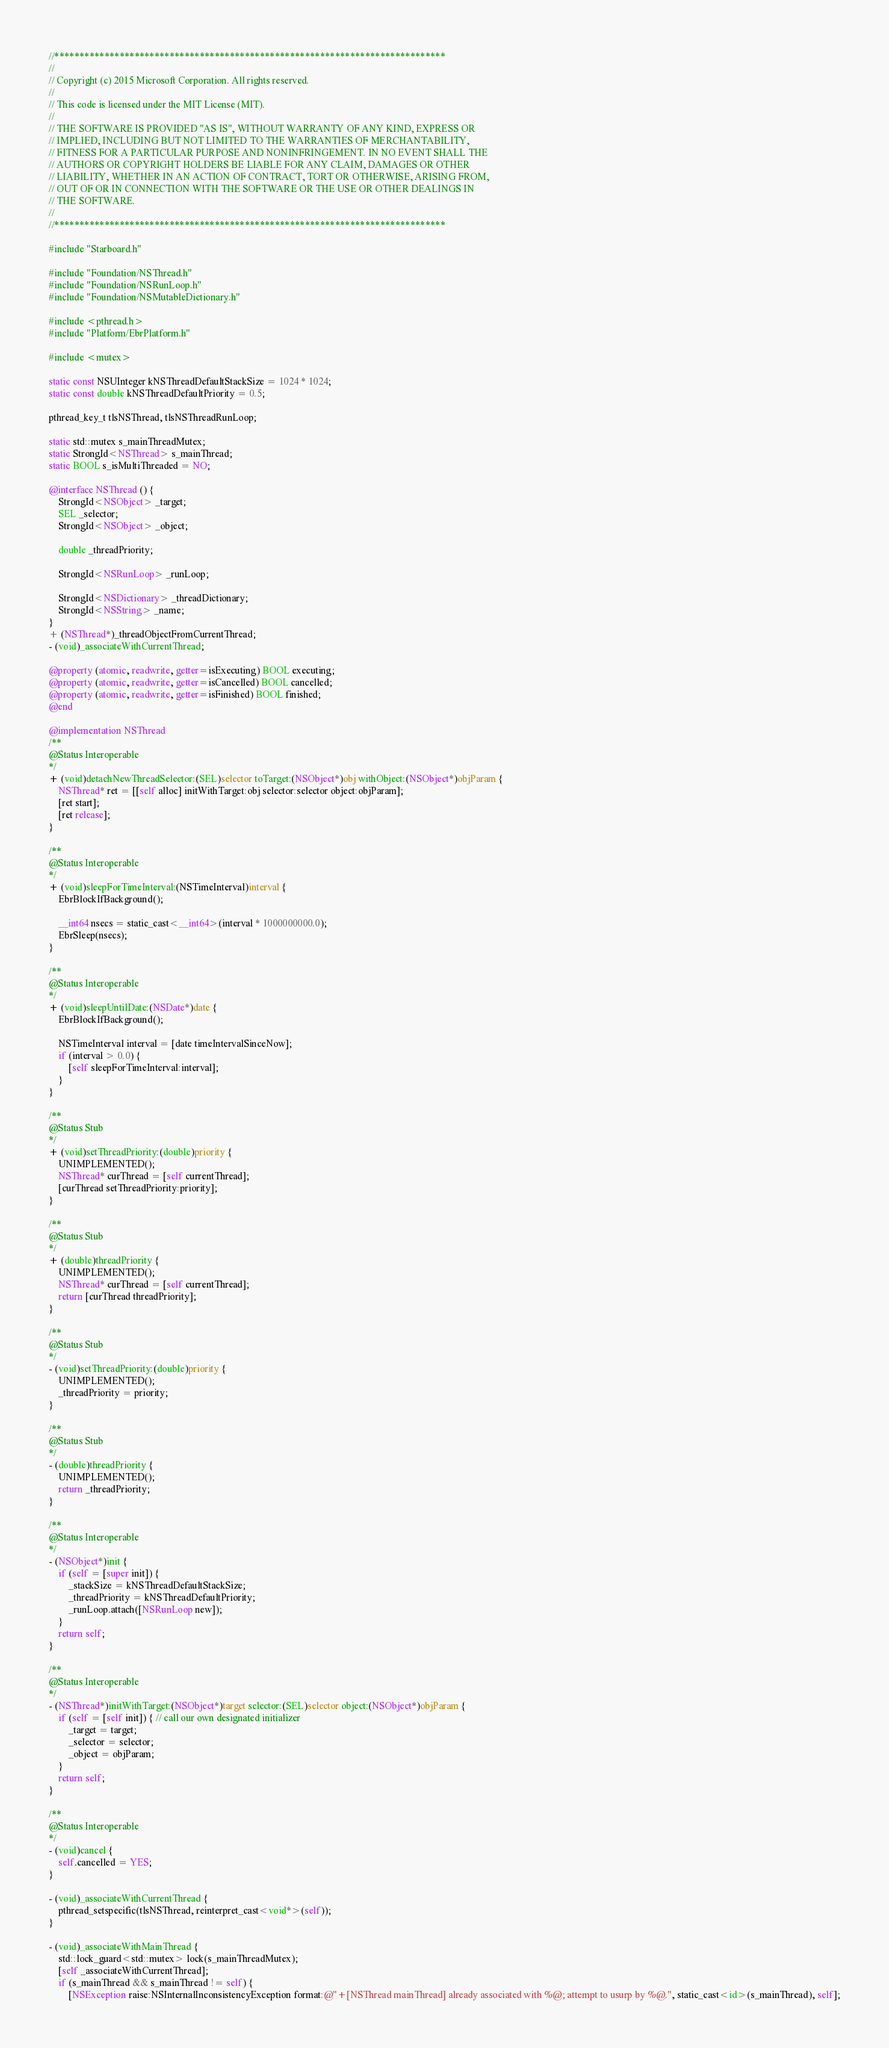Convert code to text. <code><loc_0><loc_0><loc_500><loc_500><_ObjectiveC_>//******************************************************************************
//
// Copyright (c) 2015 Microsoft Corporation. All rights reserved.
//
// This code is licensed under the MIT License (MIT).
//
// THE SOFTWARE IS PROVIDED "AS IS", WITHOUT WARRANTY OF ANY KIND, EXPRESS OR
// IMPLIED, INCLUDING BUT NOT LIMITED TO THE WARRANTIES OF MERCHANTABILITY,
// FITNESS FOR A PARTICULAR PURPOSE AND NONINFRINGEMENT. IN NO EVENT SHALL THE
// AUTHORS OR COPYRIGHT HOLDERS BE LIABLE FOR ANY CLAIM, DAMAGES OR OTHER
// LIABILITY, WHETHER IN AN ACTION OF CONTRACT, TORT OR OTHERWISE, ARISING FROM,
// OUT OF OR IN CONNECTION WITH THE SOFTWARE OR THE USE OR OTHER DEALINGS IN
// THE SOFTWARE.
//
//******************************************************************************

#include "Starboard.h"

#include "Foundation/NSThread.h"
#include "Foundation/NSRunLoop.h"
#include "Foundation/NSMutableDictionary.h"

#include <pthread.h>
#include "Platform/EbrPlatform.h"

#include <mutex>

static const NSUInteger kNSThreadDefaultStackSize = 1024 * 1024;
static const double kNSThreadDefaultPriority = 0.5;

pthread_key_t tlsNSThread, tlsNSThreadRunLoop;

static std::mutex s_mainThreadMutex;
static StrongId<NSThread> s_mainThread;
static BOOL s_isMultiThreaded = NO;

@interface NSThread () {
    StrongId<NSObject> _target;
    SEL _selector;
    StrongId<NSObject> _object;

    double _threadPriority;

    StrongId<NSRunLoop> _runLoop;

    StrongId<NSDictionary> _threadDictionary;
    StrongId<NSString> _name;
}
+ (NSThread*)_threadObjectFromCurrentThread;
- (void)_associateWithCurrentThread;

@property (atomic, readwrite, getter=isExecuting) BOOL executing;
@property (atomic, readwrite, getter=isCancelled) BOOL cancelled;
@property (atomic, readwrite, getter=isFinished) BOOL finished;
@end

@implementation NSThread
/**
@Status Interoperable
*/
+ (void)detachNewThreadSelector:(SEL)selector toTarget:(NSObject*)obj withObject:(NSObject*)objParam {
    NSThread* ret = [[self alloc] initWithTarget:obj selector:selector object:objParam];
    [ret start];
    [ret release];
}

/**
@Status Interoperable
*/
+ (void)sleepForTimeInterval:(NSTimeInterval)interval {
    EbrBlockIfBackground();

    __int64 nsecs = static_cast<__int64>(interval * 1000000000.0);
    EbrSleep(nsecs);
}

/**
@Status Interoperable
*/
+ (void)sleepUntilDate:(NSDate*)date {
    EbrBlockIfBackground();

    NSTimeInterval interval = [date timeIntervalSinceNow];
    if (interval > 0.0) {
        [self sleepForTimeInterval:interval];
    }
}

/**
@Status Stub
*/
+ (void)setThreadPriority:(double)priority {
    UNIMPLEMENTED();
    NSThread* curThread = [self currentThread];
    [curThread setThreadPriority:priority];
}

/**
@Status Stub
*/
+ (double)threadPriority {
    UNIMPLEMENTED();
    NSThread* curThread = [self currentThread];
    return [curThread threadPriority];
}

/**
@Status Stub
*/
- (void)setThreadPriority:(double)priority {
    UNIMPLEMENTED();
    _threadPriority = priority;
}

/**
@Status Stub
*/
- (double)threadPriority {
    UNIMPLEMENTED();
    return _threadPriority;
}

/**
@Status Interoperable
*/
- (NSObject*)init {
    if (self = [super init]) {
        _stackSize = kNSThreadDefaultStackSize;
        _threadPriority = kNSThreadDefaultPriority;
        _runLoop.attach([NSRunLoop new]);
    }
    return self;
}

/**
@Status Interoperable
*/
- (NSThread*)initWithTarget:(NSObject*)target selector:(SEL)selector object:(NSObject*)objParam {
    if (self = [self init]) { // call our own designated initializer
        _target = target;
        _selector = selector;
        _object = objParam;
    }
    return self;
}

/**
@Status Interoperable
*/
- (void)cancel {
    self.cancelled = YES;
}

- (void)_associateWithCurrentThread {
    pthread_setspecific(tlsNSThread, reinterpret_cast<void*>(self));
}

- (void)_associateWithMainThread {
    std::lock_guard<std::mutex> lock(s_mainThreadMutex);
    [self _associateWithCurrentThread];
    if (s_mainThread && s_mainThread != self) {
        [NSException raise:NSInternalInconsistencyException format:@"+[NSThread mainThread] already associated with %@; attempt to usurp by %@.", static_cast<id>(s_mainThread), self];</code> 